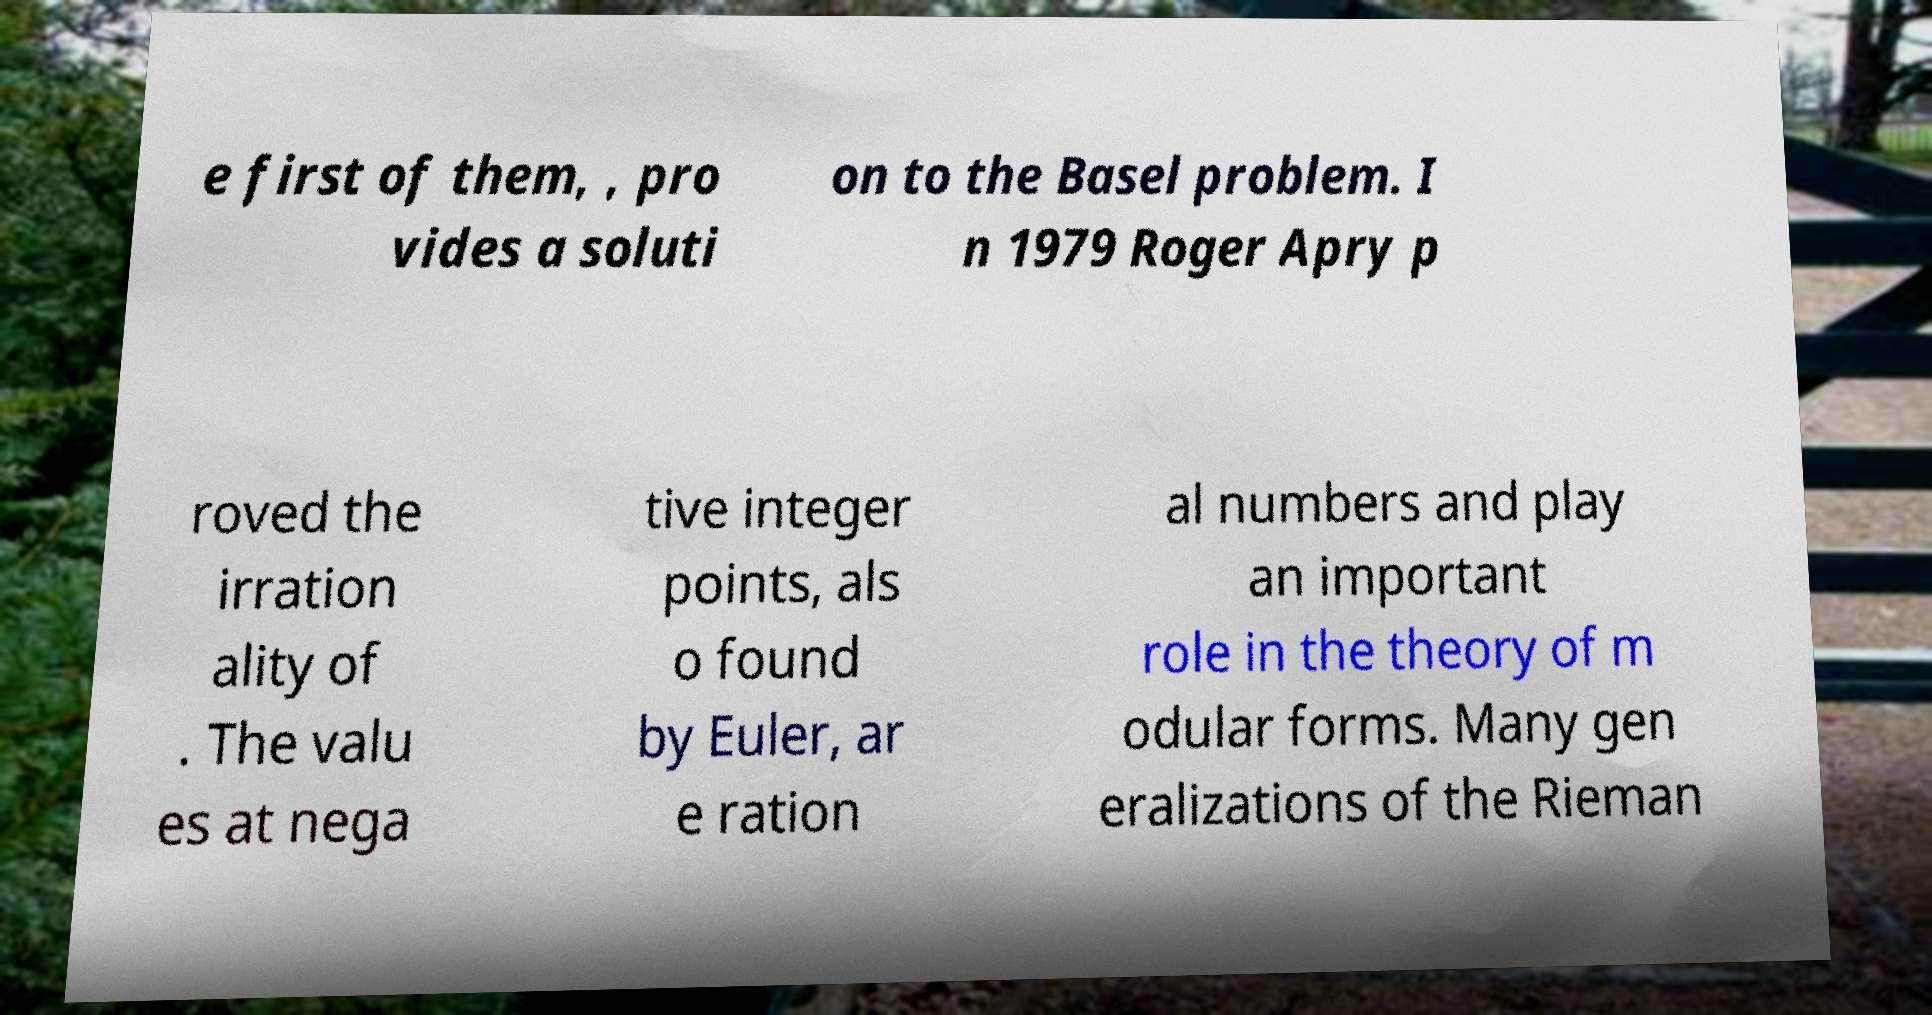Can you accurately transcribe the text from the provided image for me? e first of them, , pro vides a soluti on to the Basel problem. I n 1979 Roger Apry p roved the irration ality of . The valu es at nega tive integer points, als o found by Euler, ar e ration al numbers and play an important role in the theory of m odular forms. Many gen eralizations of the Rieman 